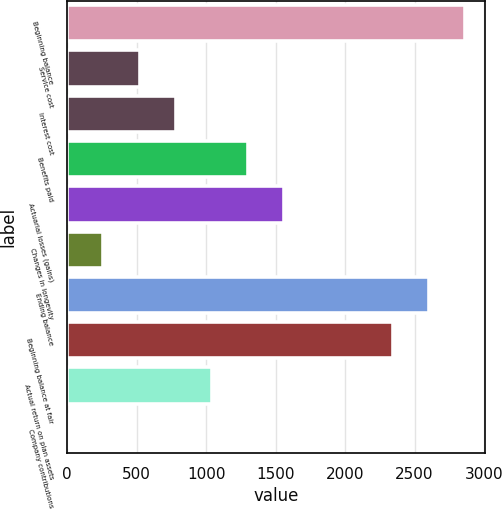Convert chart to OTSL. <chart><loc_0><loc_0><loc_500><loc_500><bar_chart><fcel>Beginning balance<fcel>Service cost<fcel>Interest cost<fcel>Benefits paid<fcel>Actuarial losses (gains)<fcel>Changes in longevity<fcel>Ending balance<fcel>Beginning balance at fair<fcel>Actual return on plan assets<fcel>Company contributions<nl><fcel>2862.1<fcel>521.2<fcel>781.3<fcel>1301.5<fcel>1561.6<fcel>261.1<fcel>2602<fcel>2341.9<fcel>1041.4<fcel>1<nl></chart> 